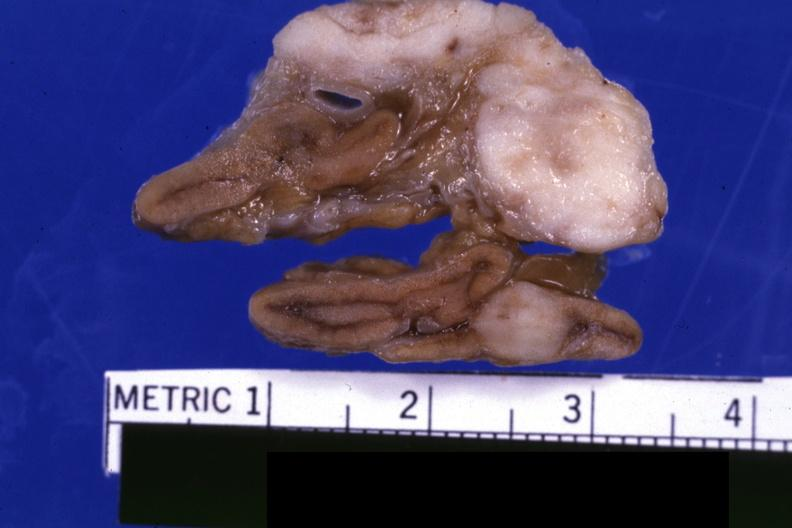s this section showing liver with tumor mass in hilar area tumor present?
Answer the question using a single word or phrase. No 